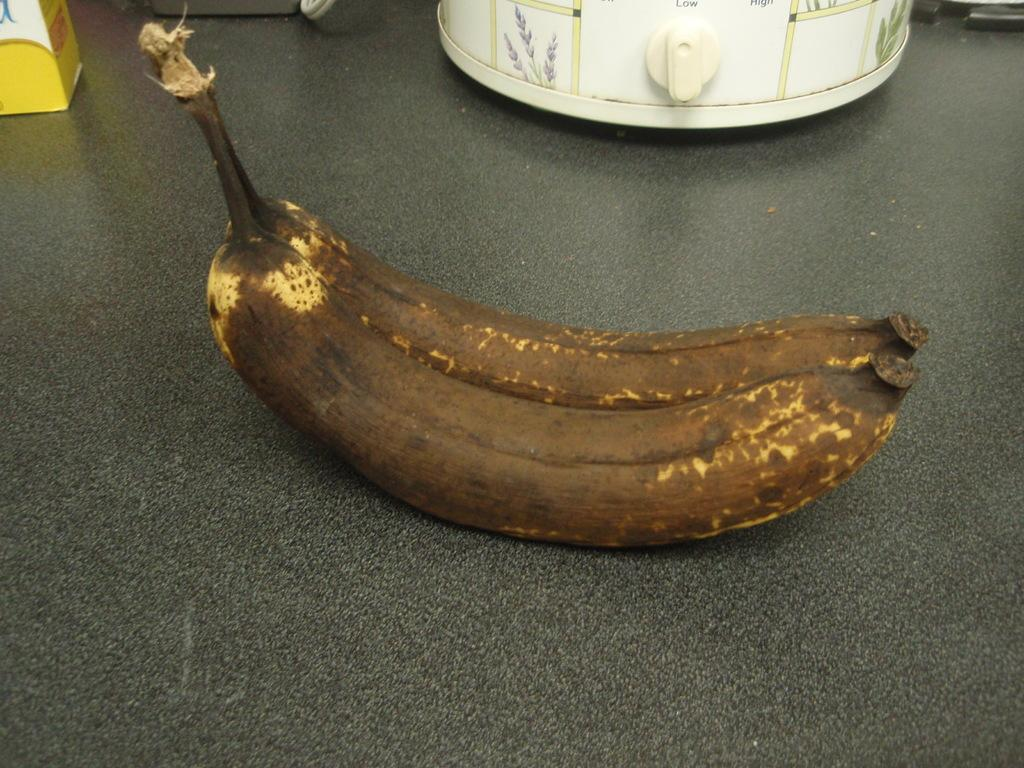What type of fruit is in the image? There is a banana in the image. Can you describe the color of the banana? The banana has yellow and brown color. On what surface is the banana placed? The banana is on some surface. What can be seen in the background of the image? There are objects in the background of the image that are white in color. What type of war is depicted in the image? There is no war depicted in the image; it features a banana with yellow and brown color on some surface. How many seeds can be seen in the banana in the image? Bananas do not have seeds that are visible to the naked eye; they have small, black seeds inside the fruit. However, the image does not show any seeds. 